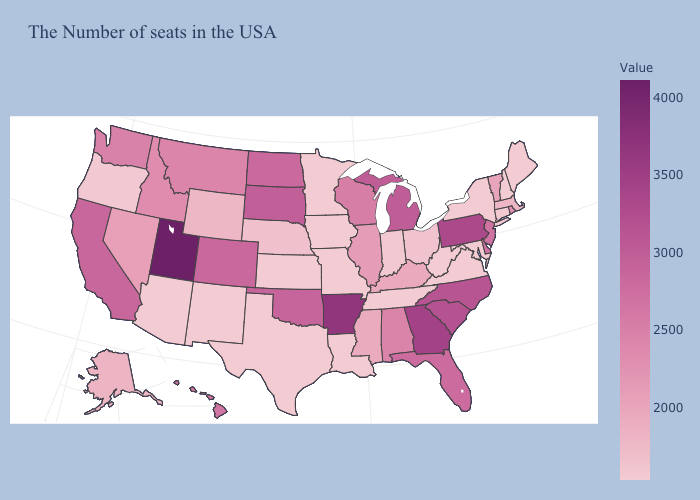Does Alabama have the lowest value in the USA?
Concise answer only. No. Does Florida have the lowest value in the USA?
Write a very short answer. No. Does Pennsylvania have the highest value in the USA?
Answer briefly. No. Among the states that border Tennessee , does Georgia have the lowest value?
Short answer required. No. Does Delaware have a higher value than Wyoming?
Keep it brief. Yes. Which states have the highest value in the USA?
Concise answer only. Utah. 